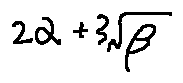Convert formula to latex. <formula><loc_0><loc_0><loc_500><loc_500>2 \alpha + 3 \sqrt { \beta }</formula> 